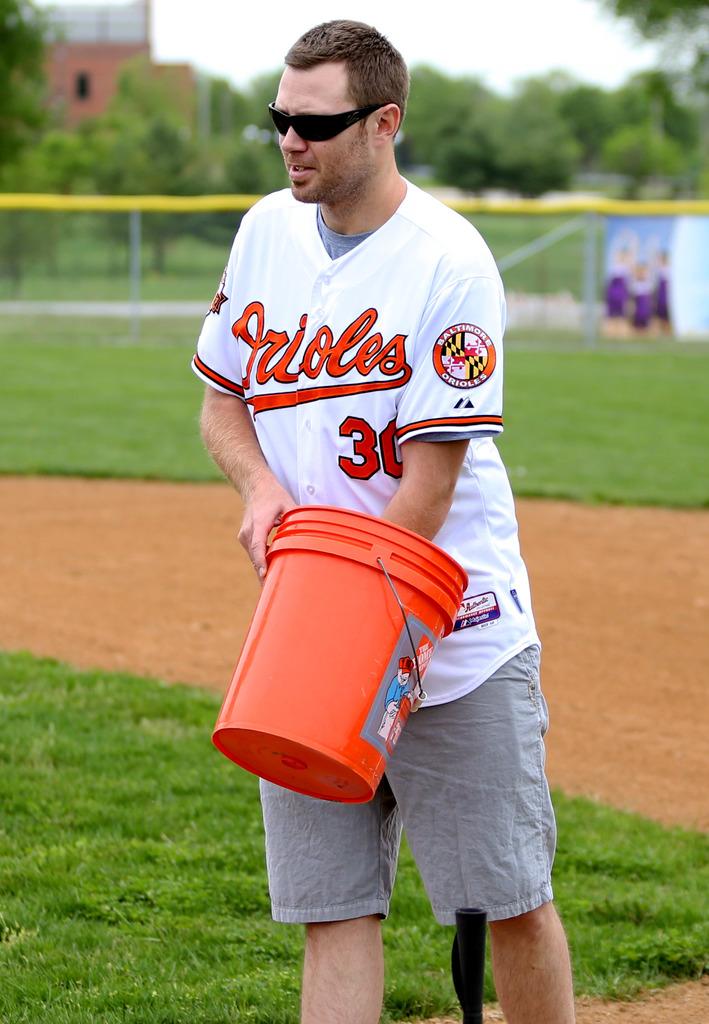What baseball team is on the jersey?
Your answer should be compact. Orioles. What is the number on the jersey?
Provide a short and direct response. 30. 